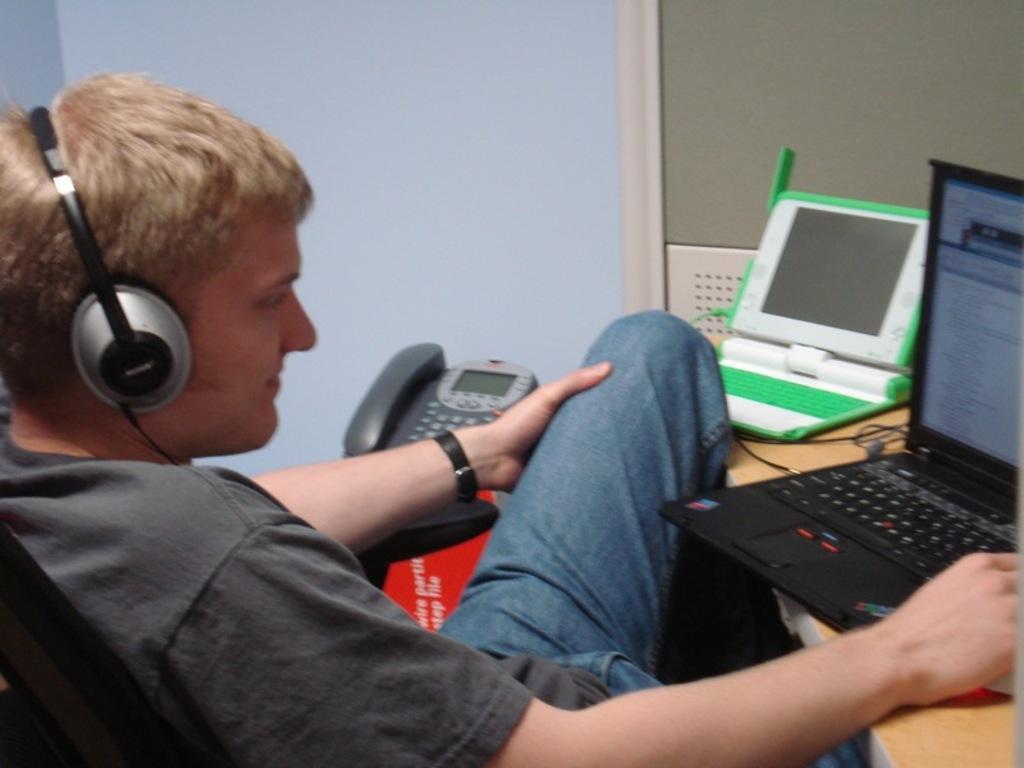How would you summarize this image in a sentence or two? In this image we can see a person with the headsets and he is sitting in front of the table. On the table we can see the laptops, wires. We can also see the wall and a phone. 